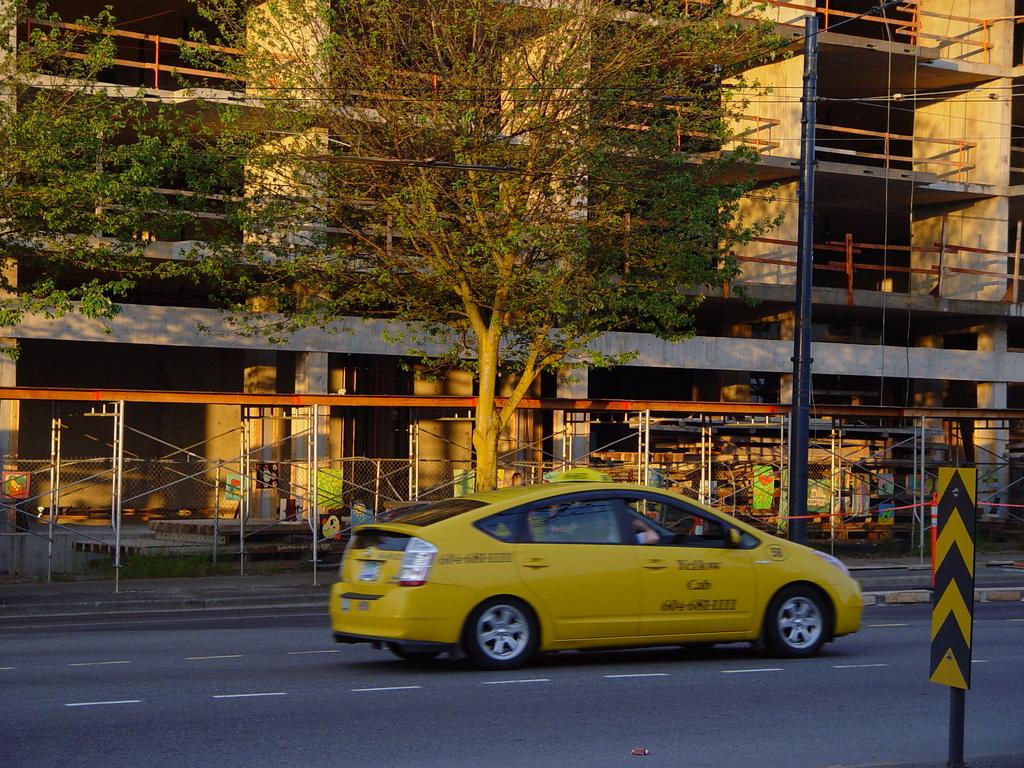Which is the cab company for this taxi?
Provide a short and direct response. Yellow cab. According to the circle on the front fender, what is this taxicab's number?
Offer a very short reply. Unanswerable. 